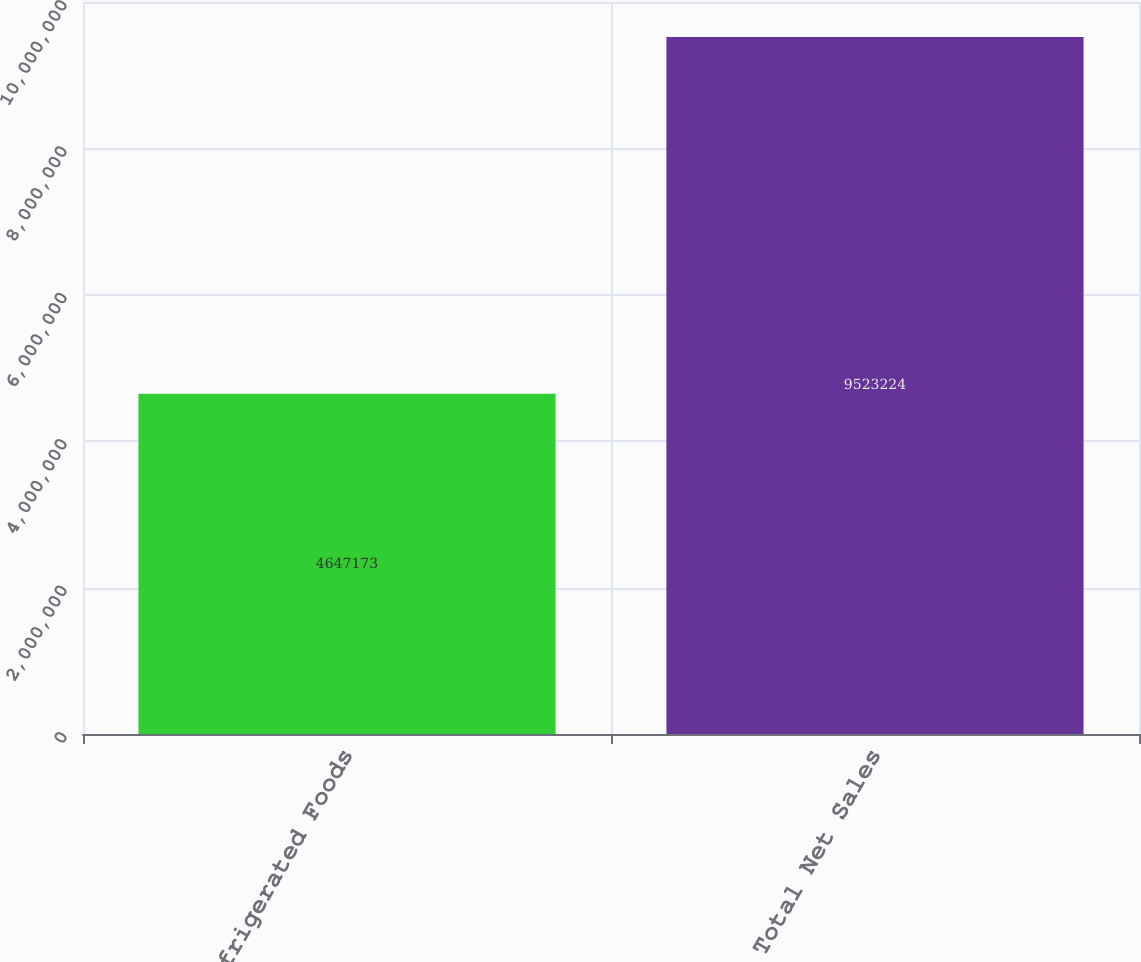Convert chart to OTSL. <chart><loc_0><loc_0><loc_500><loc_500><bar_chart><fcel>Refrigerated Foods<fcel>Total Net Sales<nl><fcel>4.64717e+06<fcel>9.52322e+06<nl></chart> 